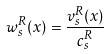Convert formula to latex. <formula><loc_0><loc_0><loc_500><loc_500>w _ { s } ^ { R } ( x ) = \frac { v _ { s } ^ { R } ( x ) } { c _ { s } ^ { R } }</formula> 